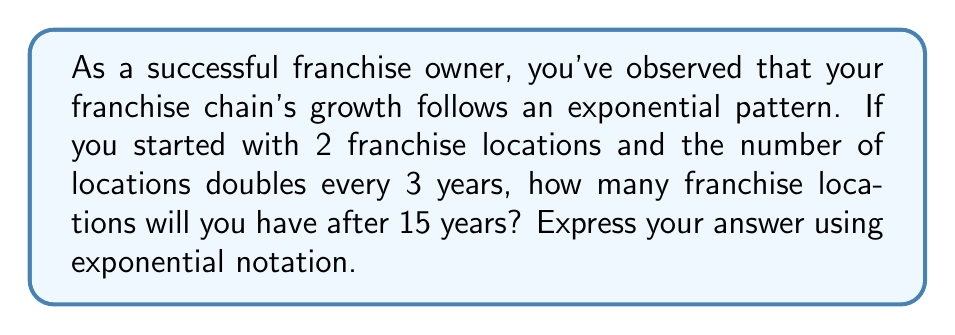Can you answer this question? Let's approach this step-by-step:

1) First, we need to identify the components of our exponential function:
   - Initial value (a): 2 franchise locations
   - Growth rate (r): doubles (×2) every 3 years
   - Time (t): 15 years

2) The general form of an exponential growth function is:

   $$A(t) = a \cdot (1 + r)^{\frac{t}{p}}$$

   Where:
   $A(t)$ is the amount after time $t$
   $a$ is the initial amount
   $r$ is the growth rate per period
   $p$ is the length of each period
   $t$ is the total time

3) In our case:
   $a = 2$
   $r = 1$ (doubling means growing by 100% or 1)
   $p = 3$ (the growth occurs every 3 years)
   $t = 15$

4) Substituting these values into our formula:

   $$A(15) = 2 \cdot (1 + 1)^{\frac{15}{3}}$$

5) Simplify:
   $$A(15) = 2 \cdot 2^5$$

6) Calculate:
   $$A(15) = 2 \cdot 32 = 64$$

Therefore, after 15 years, you will have 64 franchise locations.
Answer: $2 \cdot 2^5$ or 64 